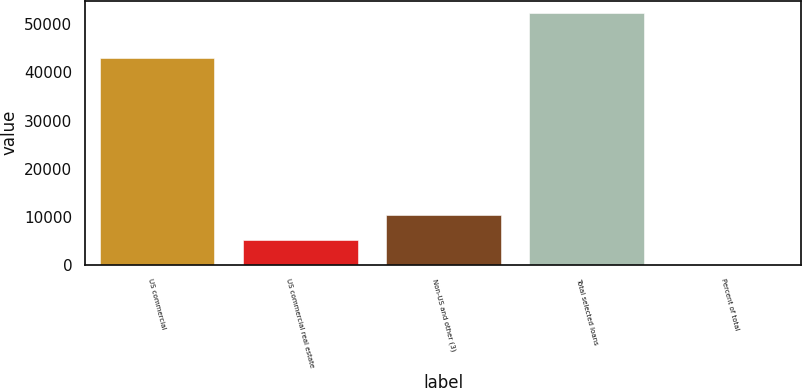Convert chart to OTSL. <chart><loc_0><loc_0><loc_500><loc_500><bar_chart><fcel>US commercial<fcel>US commercial real estate<fcel>Non-US and other (3)<fcel>Total selected loans<fcel>Percent of total<nl><fcel>42916<fcel>5244.2<fcel>10474.4<fcel>52316<fcel>14<nl></chart> 